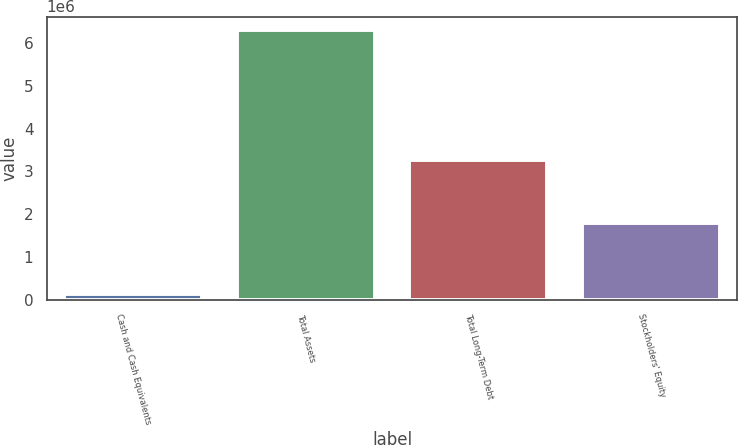Convert chart. <chart><loc_0><loc_0><loc_500><loc_500><bar_chart><fcel>Cash and Cash Equivalents<fcel>Total Assets<fcel>Total Long-Term Debt<fcel>Stockholders' Equity<nl><fcel>125607<fcel>6.30792e+06<fcel>3.26629e+06<fcel>1.79546e+06<nl></chart> 